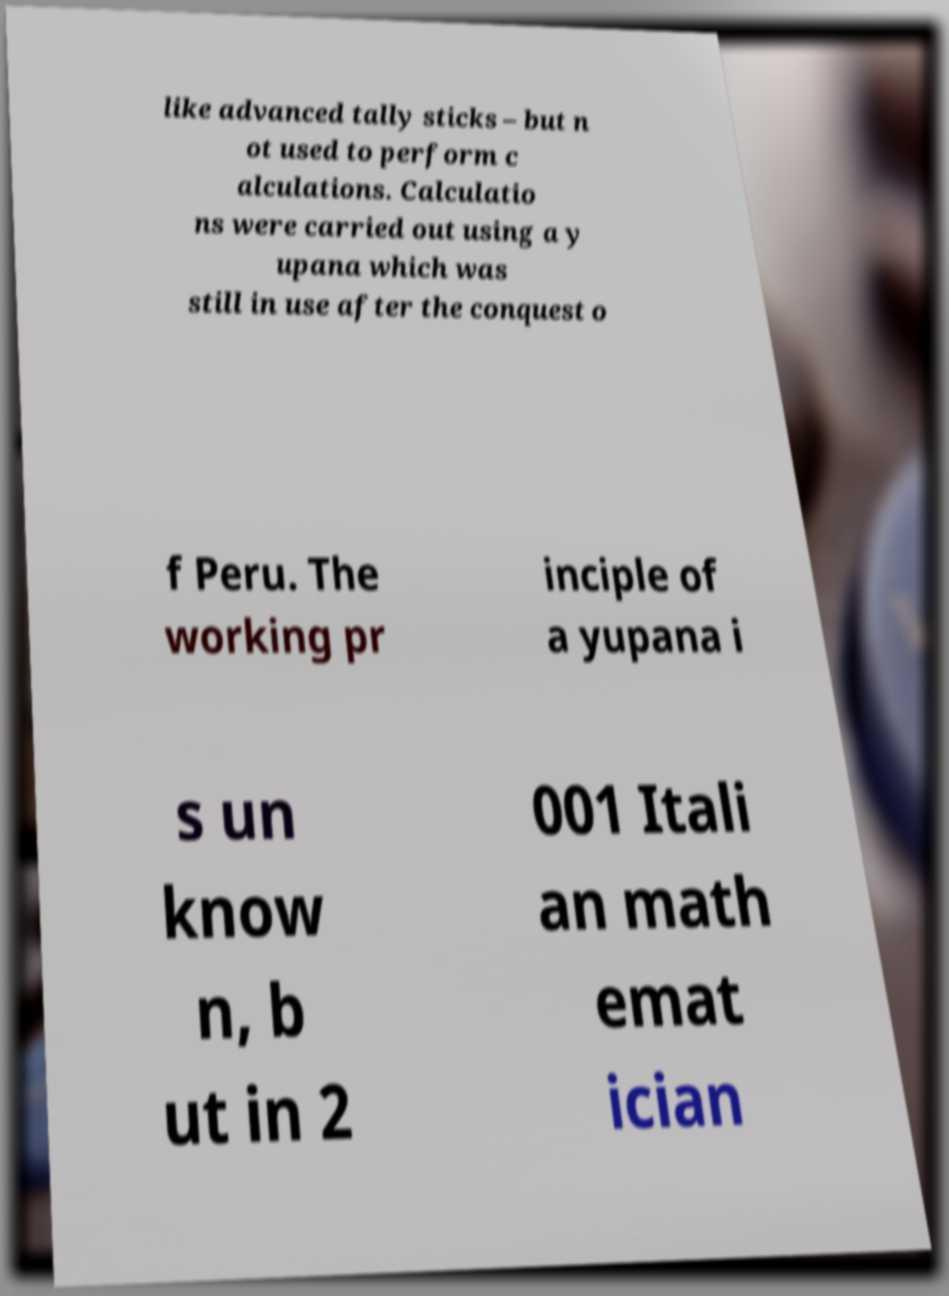Please identify and transcribe the text found in this image. like advanced tally sticks – but n ot used to perform c alculations. Calculatio ns were carried out using a y upana which was still in use after the conquest o f Peru. The working pr inciple of a yupana i s un know n, b ut in 2 001 Itali an math emat ician 